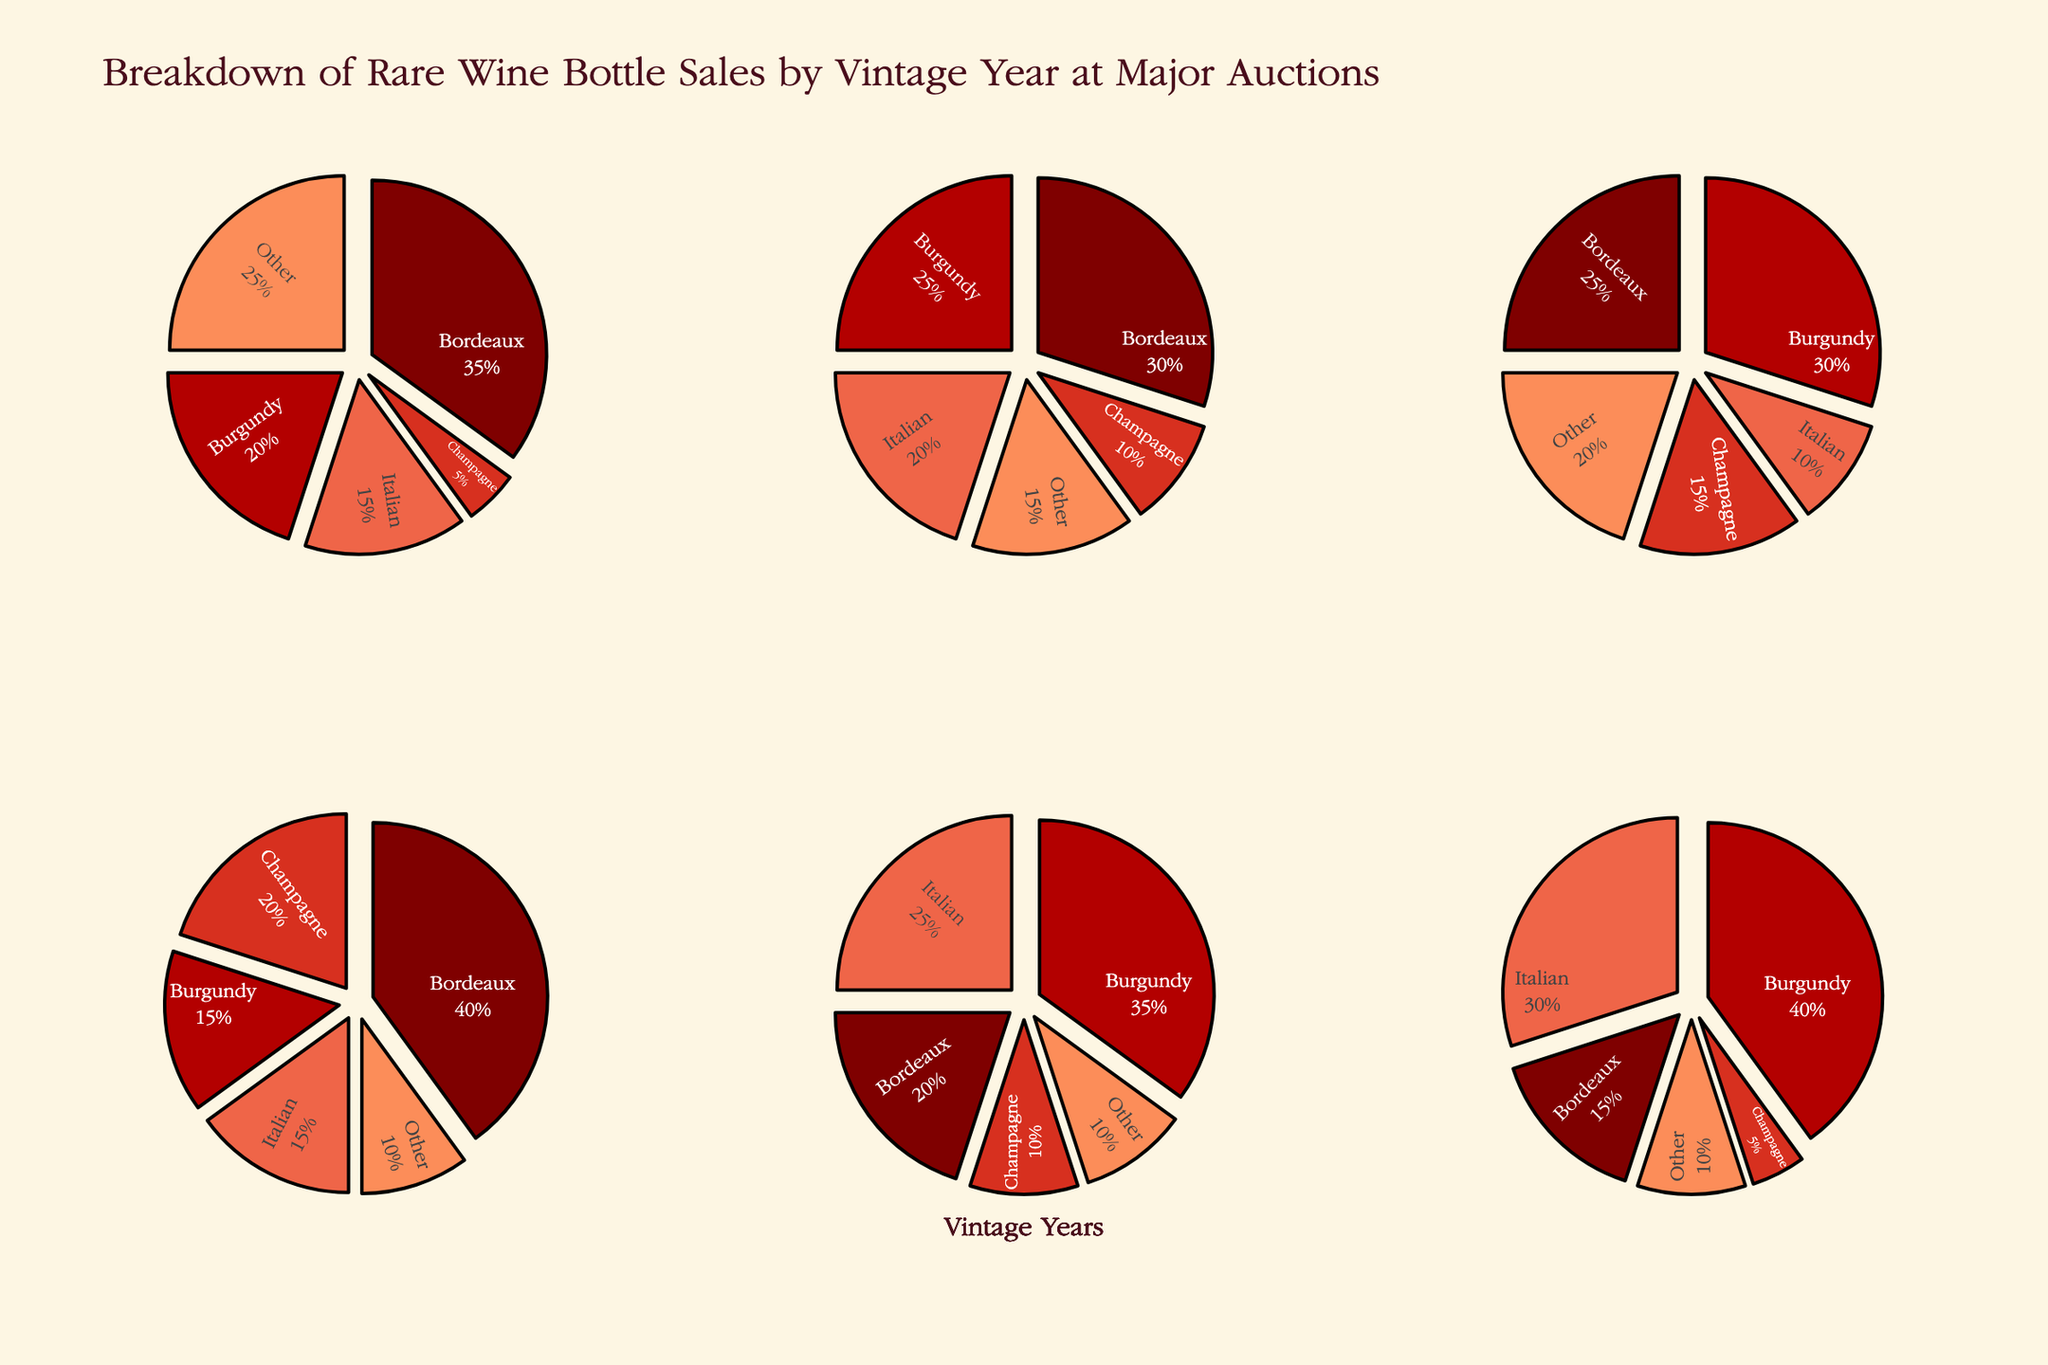What's the title of the figure? The title is usually found at the top of the figure and often provides a summary of what the figure is about.
Answer: Ukrainian Language Proficiency Across Generations Which generation has the highest proficiency on average? To determine this, look at the y-values (Proficiency) for each generation (subplots) and calculate the average. The 1st Generation seems to have higher y-values overall.
Answer: 1st Generation What is the range of language proficiency scores for the 3rd Generation? Range is the difference between the highest and lowest values. For the 3rd Generation, the highest proficiency is 55 and the lowest is 30, so the range is 55 - 30.
Answer: 25 Compare the proficiency of a 25-year-old in the 1st Generation to that of a 28-year-old in the 2nd Generation. Find the proficiency of these ages in their respective subplots. The 25-year-old in the 1st Generation has 78 proficiency, and the 28-year-old in the 2nd Generation has 72 proficiency.
Answer: 1st Generation's 25-year-old has higher proficiency Which age in the 2nd Generation has the lowest language proficiency? Inspect the subplot for the 2nd Generation and identify the point with the lowest y-value. It appears the lowest proficiency is 55 at age 60.
Answer: 60 Is there any overlap in the proficiency scores between 1st and 3rd Generations? Check if any scores in the 1st Generation's subplot match any from the 3rd Generation's subplot. There appears to be no complete overlap visually.
Answer: No What is the proficiency score of the 52-year-old in the 2nd Generation? Locate the age 52 in the 2nd Generation's subplot and read the corresponding y-value.
Answer: 65 Are there more data points in the 2nd Generation or the 3rd Generation? Count the number of markers in both the 2nd and 3rd Generation subplots. The 2nd Generation has more markers.
Answer: 2nd Generation What is the median age of individuals in the 3rd Generation group? List the ages in the 3rd Generation subplot, sort them, and then find the middle value. The ages in the 3rd Generation group are 22, 30, 40, 50, 55, 58, 65, 70. The median is the average of the 4th and 5th values, which are 50 and 55.
Answer: 52.5 